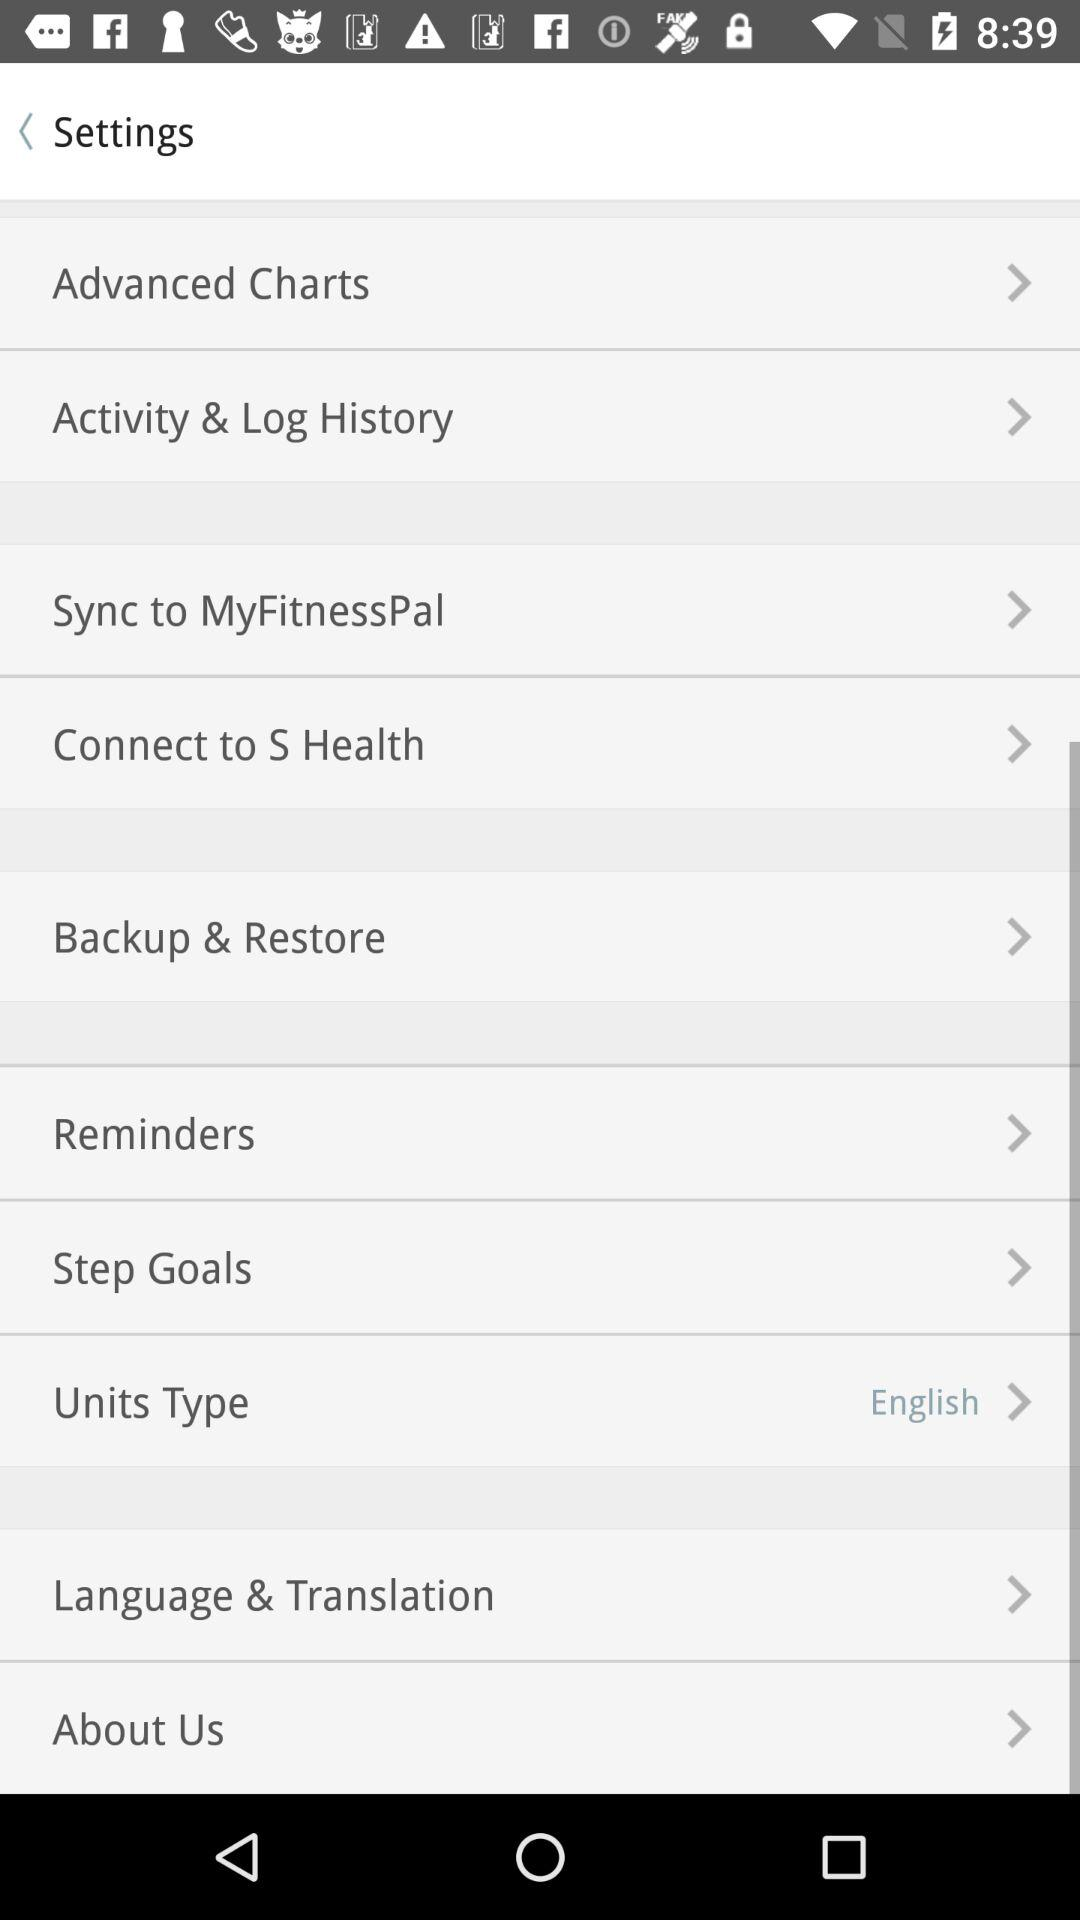Which unit type is selected? The selected unit type is English. 